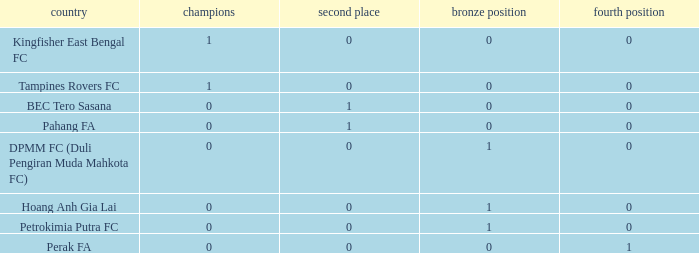Name the highest 3rd place for nation of perak fa 0.0. 